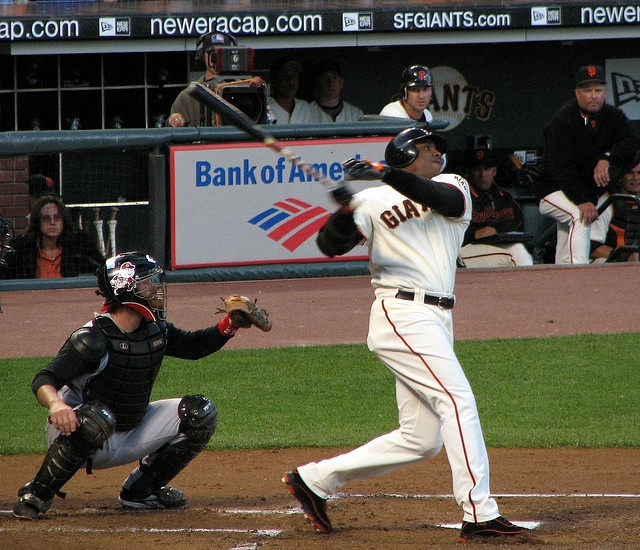Describe the objects in this image and their specific colors. I can see people in blue, white, black, darkgray, and gray tones, people in blue, black, gray, darkgray, and maroon tones, people in blue, black, darkgray, gray, and lightgray tones, people in blue, black, maroon, gray, and brown tones, and people in blue, black, maroon, and brown tones in this image. 